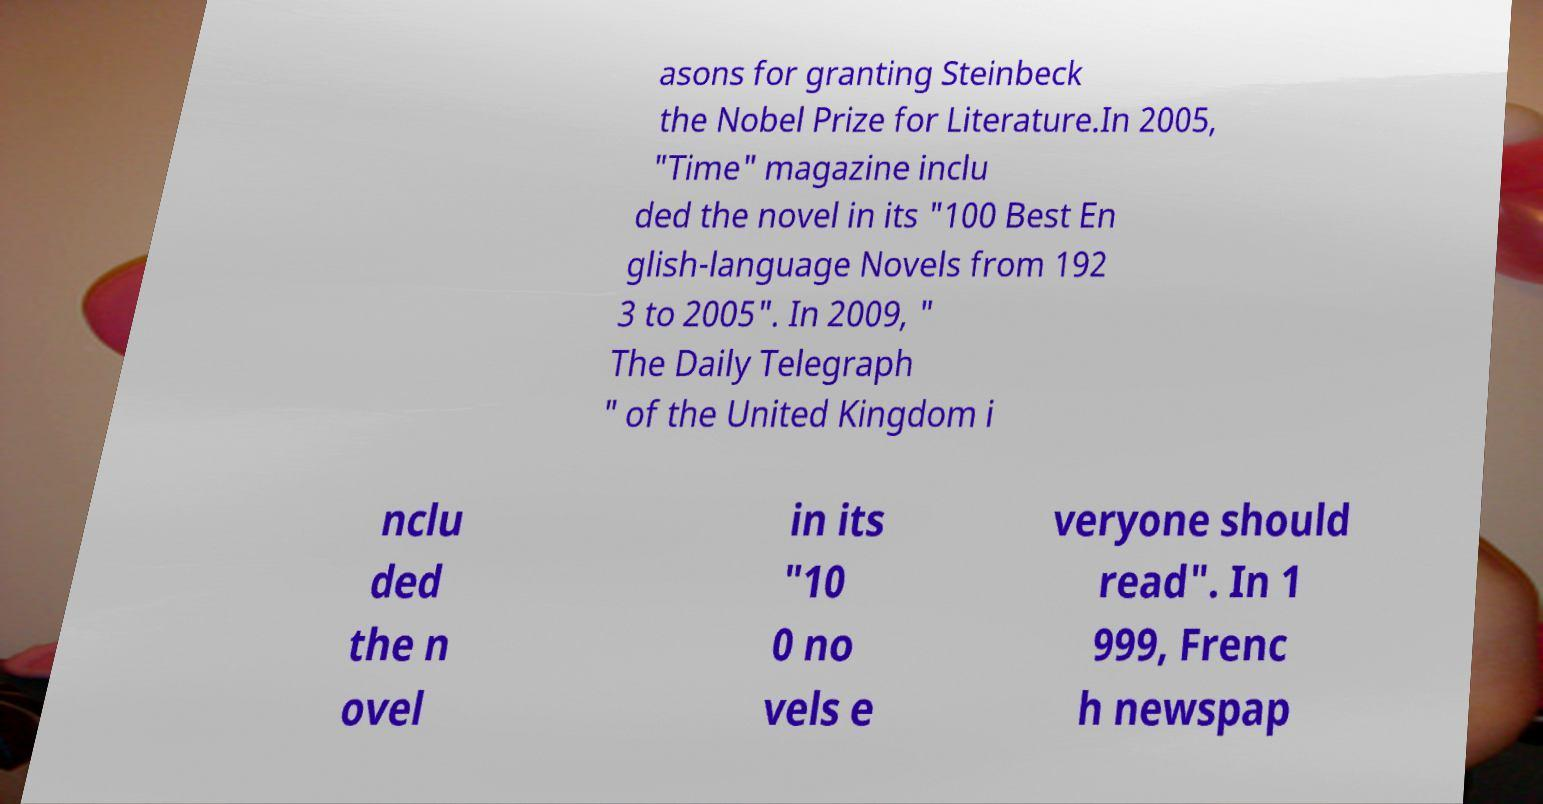Could you assist in decoding the text presented in this image and type it out clearly? asons for granting Steinbeck the Nobel Prize for Literature.In 2005, "Time" magazine inclu ded the novel in its "100 Best En glish-language Novels from 192 3 to 2005". In 2009, " The Daily Telegraph " of the United Kingdom i nclu ded the n ovel in its "10 0 no vels e veryone should read". In 1 999, Frenc h newspap 